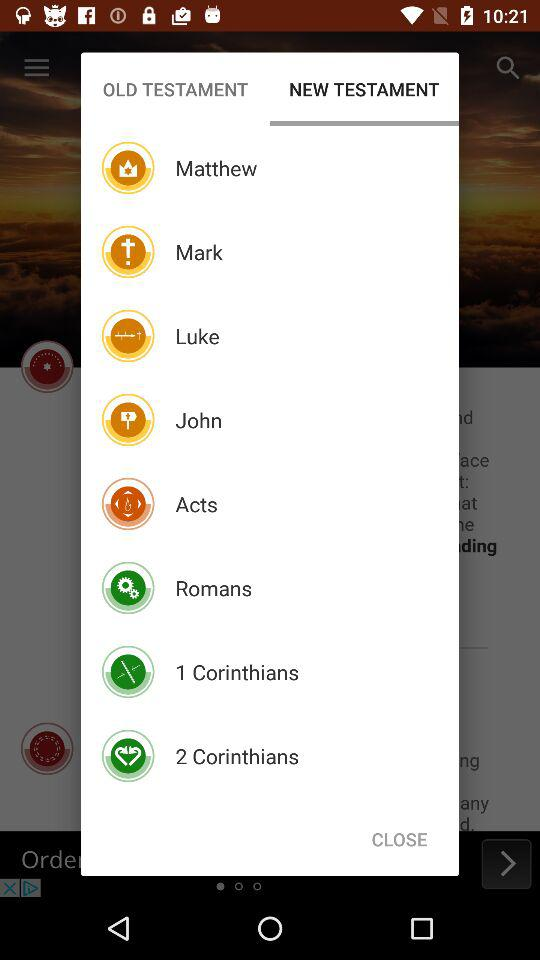Which tab is currently selected? The tab is "NEW TESTAMENT". 